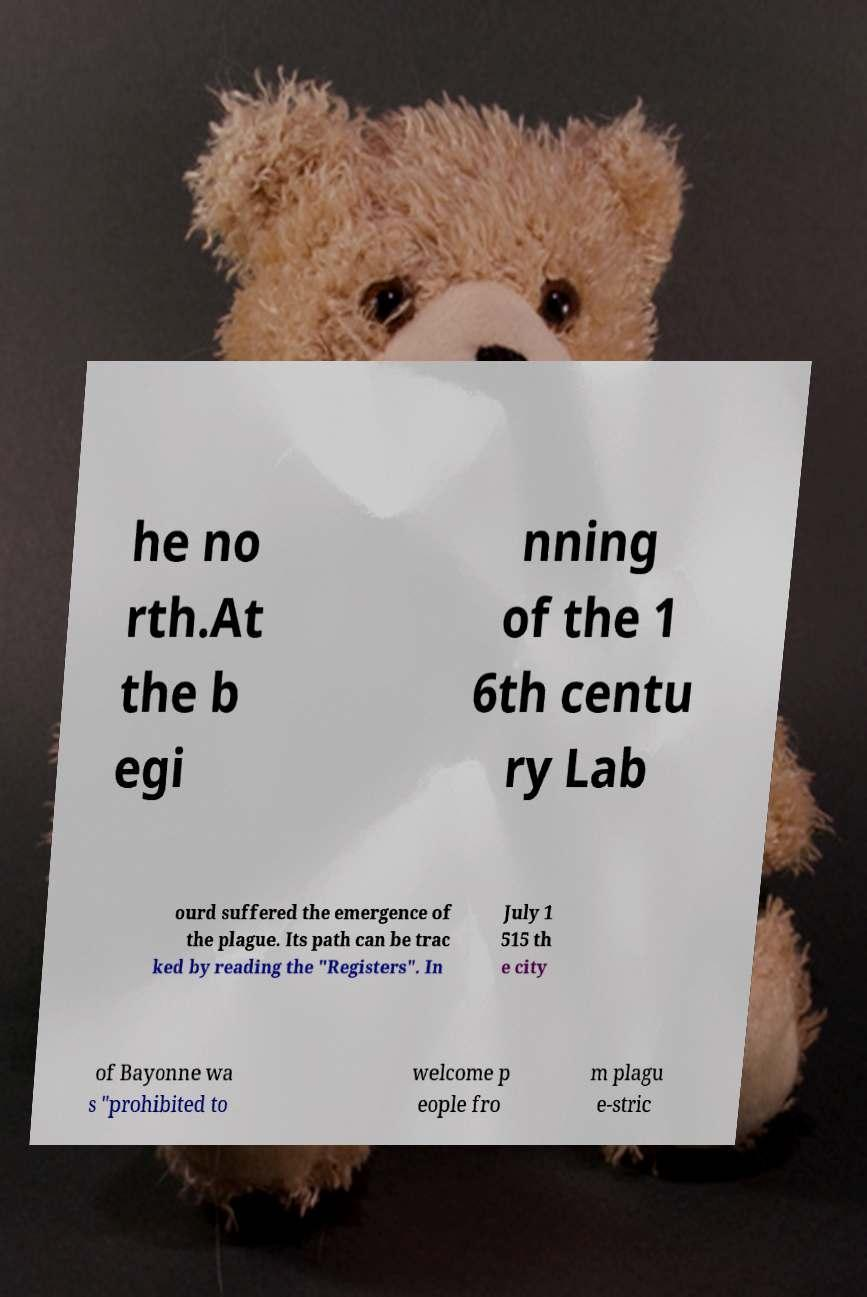What messages or text are displayed in this image? I need them in a readable, typed format. he no rth.At the b egi nning of the 1 6th centu ry Lab ourd suffered the emergence of the plague. Its path can be trac ked by reading the "Registers". In July 1 515 th e city of Bayonne wa s "prohibited to welcome p eople fro m plagu e-stric 